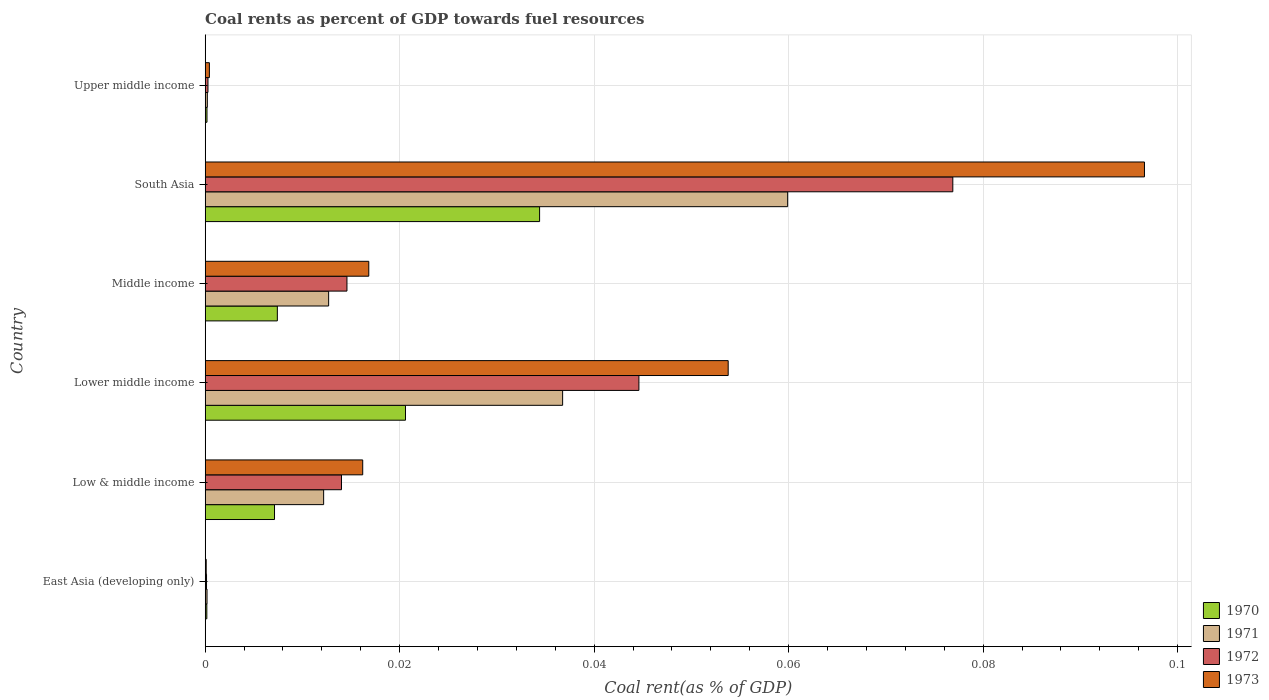How many groups of bars are there?
Provide a succinct answer. 6. Are the number of bars per tick equal to the number of legend labels?
Offer a very short reply. Yes. Are the number of bars on each tick of the Y-axis equal?
Your answer should be compact. Yes. How many bars are there on the 4th tick from the bottom?
Keep it short and to the point. 4. In how many cases, is the number of bars for a given country not equal to the number of legend labels?
Ensure brevity in your answer.  0. What is the coal rent in 1972 in East Asia (developing only)?
Keep it short and to the point. 0. Across all countries, what is the maximum coal rent in 1971?
Your answer should be compact. 0.06. Across all countries, what is the minimum coal rent in 1972?
Make the answer very short. 0. In which country was the coal rent in 1971 maximum?
Provide a short and direct response. South Asia. In which country was the coal rent in 1970 minimum?
Make the answer very short. East Asia (developing only). What is the total coal rent in 1971 in the graph?
Your response must be concise. 0.12. What is the difference between the coal rent in 1972 in Low & middle income and that in Lower middle income?
Your answer should be compact. -0.03. What is the difference between the coal rent in 1973 in Middle income and the coal rent in 1971 in Upper middle income?
Your response must be concise. 0.02. What is the average coal rent in 1973 per country?
Make the answer very short. 0.03. What is the difference between the coal rent in 1973 and coal rent in 1970 in South Asia?
Provide a short and direct response. 0.06. What is the ratio of the coal rent in 1973 in Lower middle income to that in South Asia?
Your response must be concise. 0.56. Is the coal rent in 1972 in East Asia (developing only) less than that in Upper middle income?
Make the answer very short. Yes. What is the difference between the highest and the second highest coal rent in 1970?
Provide a succinct answer. 0.01. What is the difference between the highest and the lowest coal rent in 1970?
Your response must be concise. 0.03. Is the sum of the coal rent in 1973 in Middle income and Upper middle income greater than the maximum coal rent in 1970 across all countries?
Your answer should be compact. No. What does the 2nd bar from the top in Lower middle income represents?
Offer a very short reply. 1972. What does the 4th bar from the bottom in East Asia (developing only) represents?
Your answer should be very brief. 1973. Is it the case that in every country, the sum of the coal rent in 1970 and coal rent in 1971 is greater than the coal rent in 1972?
Your response must be concise. Yes. How many bars are there?
Give a very brief answer. 24. How many countries are there in the graph?
Provide a short and direct response. 6. Does the graph contain any zero values?
Keep it short and to the point. No. Does the graph contain grids?
Keep it short and to the point. Yes. Where does the legend appear in the graph?
Make the answer very short. Bottom right. How many legend labels are there?
Give a very brief answer. 4. What is the title of the graph?
Your answer should be compact. Coal rents as percent of GDP towards fuel resources. What is the label or title of the X-axis?
Provide a short and direct response. Coal rent(as % of GDP). What is the Coal rent(as % of GDP) of 1970 in East Asia (developing only)?
Keep it short and to the point. 0. What is the Coal rent(as % of GDP) in 1971 in East Asia (developing only)?
Your response must be concise. 0. What is the Coal rent(as % of GDP) in 1972 in East Asia (developing only)?
Provide a short and direct response. 0. What is the Coal rent(as % of GDP) of 1973 in East Asia (developing only)?
Make the answer very short. 0. What is the Coal rent(as % of GDP) of 1970 in Low & middle income?
Keep it short and to the point. 0.01. What is the Coal rent(as % of GDP) in 1971 in Low & middle income?
Your answer should be very brief. 0.01. What is the Coal rent(as % of GDP) of 1972 in Low & middle income?
Provide a short and direct response. 0.01. What is the Coal rent(as % of GDP) in 1973 in Low & middle income?
Your answer should be very brief. 0.02. What is the Coal rent(as % of GDP) of 1970 in Lower middle income?
Keep it short and to the point. 0.02. What is the Coal rent(as % of GDP) in 1971 in Lower middle income?
Give a very brief answer. 0.04. What is the Coal rent(as % of GDP) of 1972 in Lower middle income?
Give a very brief answer. 0.04. What is the Coal rent(as % of GDP) of 1973 in Lower middle income?
Offer a terse response. 0.05. What is the Coal rent(as % of GDP) of 1970 in Middle income?
Your response must be concise. 0.01. What is the Coal rent(as % of GDP) in 1971 in Middle income?
Your answer should be very brief. 0.01. What is the Coal rent(as % of GDP) in 1972 in Middle income?
Ensure brevity in your answer.  0.01. What is the Coal rent(as % of GDP) in 1973 in Middle income?
Provide a succinct answer. 0.02. What is the Coal rent(as % of GDP) of 1970 in South Asia?
Your response must be concise. 0.03. What is the Coal rent(as % of GDP) in 1971 in South Asia?
Offer a terse response. 0.06. What is the Coal rent(as % of GDP) in 1972 in South Asia?
Give a very brief answer. 0.08. What is the Coal rent(as % of GDP) in 1973 in South Asia?
Keep it short and to the point. 0.1. What is the Coal rent(as % of GDP) of 1970 in Upper middle income?
Your answer should be very brief. 0. What is the Coal rent(as % of GDP) in 1971 in Upper middle income?
Your answer should be compact. 0. What is the Coal rent(as % of GDP) in 1972 in Upper middle income?
Offer a terse response. 0. What is the Coal rent(as % of GDP) in 1973 in Upper middle income?
Ensure brevity in your answer.  0. Across all countries, what is the maximum Coal rent(as % of GDP) of 1970?
Make the answer very short. 0.03. Across all countries, what is the maximum Coal rent(as % of GDP) of 1971?
Your answer should be very brief. 0.06. Across all countries, what is the maximum Coal rent(as % of GDP) in 1972?
Offer a very short reply. 0.08. Across all countries, what is the maximum Coal rent(as % of GDP) of 1973?
Provide a short and direct response. 0.1. Across all countries, what is the minimum Coal rent(as % of GDP) of 1970?
Ensure brevity in your answer.  0. Across all countries, what is the minimum Coal rent(as % of GDP) of 1971?
Provide a succinct answer. 0. Across all countries, what is the minimum Coal rent(as % of GDP) of 1972?
Ensure brevity in your answer.  0. Across all countries, what is the minimum Coal rent(as % of GDP) in 1973?
Your response must be concise. 0. What is the total Coal rent(as % of GDP) in 1970 in the graph?
Your answer should be compact. 0.07. What is the total Coal rent(as % of GDP) of 1971 in the graph?
Offer a very short reply. 0.12. What is the total Coal rent(as % of GDP) in 1972 in the graph?
Make the answer very short. 0.15. What is the total Coal rent(as % of GDP) in 1973 in the graph?
Ensure brevity in your answer.  0.18. What is the difference between the Coal rent(as % of GDP) in 1970 in East Asia (developing only) and that in Low & middle income?
Offer a very short reply. -0.01. What is the difference between the Coal rent(as % of GDP) of 1971 in East Asia (developing only) and that in Low & middle income?
Give a very brief answer. -0.01. What is the difference between the Coal rent(as % of GDP) in 1972 in East Asia (developing only) and that in Low & middle income?
Your answer should be compact. -0.01. What is the difference between the Coal rent(as % of GDP) in 1973 in East Asia (developing only) and that in Low & middle income?
Provide a short and direct response. -0.02. What is the difference between the Coal rent(as % of GDP) in 1970 in East Asia (developing only) and that in Lower middle income?
Provide a succinct answer. -0.02. What is the difference between the Coal rent(as % of GDP) in 1971 in East Asia (developing only) and that in Lower middle income?
Your answer should be very brief. -0.04. What is the difference between the Coal rent(as % of GDP) in 1972 in East Asia (developing only) and that in Lower middle income?
Your answer should be compact. -0.04. What is the difference between the Coal rent(as % of GDP) of 1973 in East Asia (developing only) and that in Lower middle income?
Provide a succinct answer. -0.05. What is the difference between the Coal rent(as % of GDP) in 1970 in East Asia (developing only) and that in Middle income?
Your answer should be compact. -0.01. What is the difference between the Coal rent(as % of GDP) in 1971 in East Asia (developing only) and that in Middle income?
Provide a short and direct response. -0.01. What is the difference between the Coal rent(as % of GDP) of 1972 in East Asia (developing only) and that in Middle income?
Ensure brevity in your answer.  -0.01. What is the difference between the Coal rent(as % of GDP) in 1973 in East Asia (developing only) and that in Middle income?
Offer a very short reply. -0.02. What is the difference between the Coal rent(as % of GDP) in 1970 in East Asia (developing only) and that in South Asia?
Your answer should be compact. -0.03. What is the difference between the Coal rent(as % of GDP) of 1971 in East Asia (developing only) and that in South Asia?
Your answer should be compact. -0.06. What is the difference between the Coal rent(as % of GDP) in 1972 in East Asia (developing only) and that in South Asia?
Offer a very short reply. -0.08. What is the difference between the Coal rent(as % of GDP) in 1973 in East Asia (developing only) and that in South Asia?
Give a very brief answer. -0.1. What is the difference between the Coal rent(as % of GDP) of 1970 in East Asia (developing only) and that in Upper middle income?
Provide a short and direct response. -0. What is the difference between the Coal rent(as % of GDP) in 1972 in East Asia (developing only) and that in Upper middle income?
Your answer should be very brief. -0. What is the difference between the Coal rent(as % of GDP) in 1973 in East Asia (developing only) and that in Upper middle income?
Offer a very short reply. -0. What is the difference between the Coal rent(as % of GDP) in 1970 in Low & middle income and that in Lower middle income?
Make the answer very short. -0.01. What is the difference between the Coal rent(as % of GDP) of 1971 in Low & middle income and that in Lower middle income?
Provide a short and direct response. -0.02. What is the difference between the Coal rent(as % of GDP) of 1972 in Low & middle income and that in Lower middle income?
Keep it short and to the point. -0.03. What is the difference between the Coal rent(as % of GDP) in 1973 in Low & middle income and that in Lower middle income?
Provide a succinct answer. -0.04. What is the difference between the Coal rent(as % of GDP) of 1970 in Low & middle income and that in Middle income?
Your answer should be compact. -0. What is the difference between the Coal rent(as % of GDP) in 1971 in Low & middle income and that in Middle income?
Your answer should be very brief. -0. What is the difference between the Coal rent(as % of GDP) in 1972 in Low & middle income and that in Middle income?
Provide a succinct answer. -0. What is the difference between the Coal rent(as % of GDP) of 1973 in Low & middle income and that in Middle income?
Keep it short and to the point. -0. What is the difference between the Coal rent(as % of GDP) of 1970 in Low & middle income and that in South Asia?
Your answer should be very brief. -0.03. What is the difference between the Coal rent(as % of GDP) of 1971 in Low & middle income and that in South Asia?
Provide a short and direct response. -0.05. What is the difference between the Coal rent(as % of GDP) of 1972 in Low & middle income and that in South Asia?
Offer a very short reply. -0.06. What is the difference between the Coal rent(as % of GDP) in 1973 in Low & middle income and that in South Asia?
Make the answer very short. -0.08. What is the difference between the Coal rent(as % of GDP) of 1970 in Low & middle income and that in Upper middle income?
Offer a terse response. 0.01. What is the difference between the Coal rent(as % of GDP) of 1971 in Low & middle income and that in Upper middle income?
Give a very brief answer. 0.01. What is the difference between the Coal rent(as % of GDP) of 1972 in Low & middle income and that in Upper middle income?
Keep it short and to the point. 0.01. What is the difference between the Coal rent(as % of GDP) of 1973 in Low & middle income and that in Upper middle income?
Ensure brevity in your answer.  0.02. What is the difference between the Coal rent(as % of GDP) in 1970 in Lower middle income and that in Middle income?
Keep it short and to the point. 0.01. What is the difference between the Coal rent(as % of GDP) in 1971 in Lower middle income and that in Middle income?
Give a very brief answer. 0.02. What is the difference between the Coal rent(as % of GDP) of 1972 in Lower middle income and that in Middle income?
Ensure brevity in your answer.  0.03. What is the difference between the Coal rent(as % of GDP) of 1973 in Lower middle income and that in Middle income?
Offer a very short reply. 0.04. What is the difference between the Coal rent(as % of GDP) of 1970 in Lower middle income and that in South Asia?
Keep it short and to the point. -0.01. What is the difference between the Coal rent(as % of GDP) in 1971 in Lower middle income and that in South Asia?
Give a very brief answer. -0.02. What is the difference between the Coal rent(as % of GDP) in 1972 in Lower middle income and that in South Asia?
Ensure brevity in your answer.  -0.03. What is the difference between the Coal rent(as % of GDP) of 1973 in Lower middle income and that in South Asia?
Your answer should be compact. -0.04. What is the difference between the Coal rent(as % of GDP) of 1970 in Lower middle income and that in Upper middle income?
Your response must be concise. 0.02. What is the difference between the Coal rent(as % of GDP) in 1971 in Lower middle income and that in Upper middle income?
Offer a very short reply. 0.04. What is the difference between the Coal rent(as % of GDP) of 1972 in Lower middle income and that in Upper middle income?
Provide a short and direct response. 0.04. What is the difference between the Coal rent(as % of GDP) of 1973 in Lower middle income and that in Upper middle income?
Your answer should be very brief. 0.05. What is the difference between the Coal rent(as % of GDP) in 1970 in Middle income and that in South Asia?
Your response must be concise. -0.03. What is the difference between the Coal rent(as % of GDP) of 1971 in Middle income and that in South Asia?
Your answer should be very brief. -0.05. What is the difference between the Coal rent(as % of GDP) in 1972 in Middle income and that in South Asia?
Provide a succinct answer. -0.06. What is the difference between the Coal rent(as % of GDP) in 1973 in Middle income and that in South Asia?
Make the answer very short. -0.08. What is the difference between the Coal rent(as % of GDP) of 1970 in Middle income and that in Upper middle income?
Your answer should be very brief. 0.01. What is the difference between the Coal rent(as % of GDP) in 1971 in Middle income and that in Upper middle income?
Provide a succinct answer. 0.01. What is the difference between the Coal rent(as % of GDP) in 1972 in Middle income and that in Upper middle income?
Make the answer very short. 0.01. What is the difference between the Coal rent(as % of GDP) in 1973 in Middle income and that in Upper middle income?
Give a very brief answer. 0.02. What is the difference between the Coal rent(as % of GDP) of 1970 in South Asia and that in Upper middle income?
Make the answer very short. 0.03. What is the difference between the Coal rent(as % of GDP) of 1971 in South Asia and that in Upper middle income?
Offer a very short reply. 0.06. What is the difference between the Coal rent(as % of GDP) of 1972 in South Asia and that in Upper middle income?
Offer a very short reply. 0.08. What is the difference between the Coal rent(as % of GDP) in 1973 in South Asia and that in Upper middle income?
Provide a short and direct response. 0.1. What is the difference between the Coal rent(as % of GDP) in 1970 in East Asia (developing only) and the Coal rent(as % of GDP) in 1971 in Low & middle income?
Keep it short and to the point. -0.01. What is the difference between the Coal rent(as % of GDP) in 1970 in East Asia (developing only) and the Coal rent(as % of GDP) in 1972 in Low & middle income?
Ensure brevity in your answer.  -0.01. What is the difference between the Coal rent(as % of GDP) in 1970 in East Asia (developing only) and the Coal rent(as % of GDP) in 1973 in Low & middle income?
Your answer should be very brief. -0.02. What is the difference between the Coal rent(as % of GDP) in 1971 in East Asia (developing only) and the Coal rent(as % of GDP) in 1972 in Low & middle income?
Provide a succinct answer. -0.01. What is the difference between the Coal rent(as % of GDP) in 1971 in East Asia (developing only) and the Coal rent(as % of GDP) in 1973 in Low & middle income?
Give a very brief answer. -0.02. What is the difference between the Coal rent(as % of GDP) of 1972 in East Asia (developing only) and the Coal rent(as % of GDP) of 1973 in Low & middle income?
Provide a short and direct response. -0.02. What is the difference between the Coal rent(as % of GDP) of 1970 in East Asia (developing only) and the Coal rent(as % of GDP) of 1971 in Lower middle income?
Offer a terse response. -0.04. What is the difference between the Coal rent(as % of GDP) of 1970 in East Asia (developing only) and the Coal rent(as % of GDP) of 1972 in Lower middle income?
Give a very brief answer. -0.04. What is the difference between the Coal rent(as % of GDP) of 1970 in East Asia (developing only) and the Coal rent(as % of GDP) of 1973 in Lower middle income?
Offer a terse response. -0.05. What is the difference between the Coal rent(as % of GDP) in 1971 in East Asia (developing only) and the Coal rent(as % of GDP) in 1972 in Lower middle income?
Make the answer very short. -0.04. What is the difference between the Coal rent(as % of GDP) of 1971 in East Asia (developing only) and the Coal rent(as % of GDP) of 1973 in Lower middle income?
Make the answer very short. -0.05. What is the difference between the Coal rent(as % of GDP) of 1972 in East Asia (developing only) and the Coal rent(as % of GDP) of 1973 in Lower middle income?
Keep it short and to the point. -0.05. What is the difference between the Coal rent(as % of GDP) in 1970 in East Asia (developing only) and the Coal rent(as % of GDP) in 1971 in Middle income?
Your answer should be very brief. -0.01. What is the difference between the Coal rent(as % of GDP) of 1970 in East Asia (developing only) and the Coal rent(as % of GDP) of 1972 in Middle income?
Ensure brevity in your answer.  -0.01. What is the difference between the Coal rent(as % of GDP) of 1970 in East Asia (developing only) and the Coal rent(as % of GDP) of 1973 in Middle income?
Provide a short and direct response. -0.02. What is the difference between the Coal rent(as % of GDP) in 1971 in East Asia (developing only) and the Coal rent(as % of GDP) in 1972 in Middle income?
Make the answer very short. -0.01. What is the difference between the Coal rent(as % of GDP) in 1971 in East Asia (developing only) and the Coal rent(as % of GDP) in 1973 in Middle income?
Your answer should be very brief. -0.02. What is the difference between the Coal rent(as % of GDP) in 1972 in East Asia (developing only) and the Coal rent(as % of GDP) in 1973 in Middle income?
Provide a succinct answer. -0.02. What is the difference between the Coal rent(as % of GDP) of 1970 in East Asia (developing only) and the Coal rent(as % of GDP) of 1971 in South Asia?
Your answer should be very brief. -0.06. What is the difference between the Coal rent(as % of GDP) in 1970 in East Asia (developing only) and the Coal rent(as % of GDP) in 1972 in South Asia?
Your answer should be very brief. -0.08. What is the difference between the Coal rent(as % of GDP) in 1970 in East Asia (developing only) and the Coal rent(as % of GDP) in 1973 in South Asia?
Ensure brevity in your answer.  -0.1. What is the difference between the Coal rent(as % of GDP) of 1971 in East Asia (developing only) and the Coal rent(as % of GDP) of 1972 in South Asia?
Make the answer very short. -0.08. What is the difference between the Coal rent(as % of GDP) of 1971 in East Asia (developing only) and the Coal rent(as % of GDP) of 1973 in South Asia?
Keep it short and to the point. -0.1. What is the difference between the Coal rent(as % of GDP) in 1972 in East Asia (developing only) and the Coal rent(as % of GDP) in 1973 in South Asia?
Offer a very short reply. -0.1. What is the difference between the Coal rent(as % of GDP) of 1970 in East Asia (developing only) and the Coal rent(as % of GDP) of 1971 in Upper middle income?
Keep it short and to the point. -0. What is the difference between the Coal rent(as % of GDP) in 1970 in East Asia (developing only) and the Coal rent(as % of GDP) in 1972 in Upper middle income?
Your response must be concise. -0. What is the difference between the Coal rent(as % of GDP) of 1970 in East Asia (developing only) and the Coal rent(as % of GDP) of 1973 in Upper middle income?
Give a very brief answer. -0. What is the difference between the Coal rent(as % of GDP) of 1971 in East Asia (developing only) and the Coal rent(as % of GDP) of 1972 in Upper middle income?
Offer a very short reply. -0. What is the difference between the Coal rent(as % of GDP) in 1971 in East Asia (developing only) and the Coal rent(as % of GDP) in 1973 in Upper middle income?
Give a very brief answer. -0. What is the difference between the Coal rent(as % of GDP) in 1972 in East Asia (developing only) and the Coal rent(as % of GDP) in 1973 in Upper middle income?
Your response must be concise. -0. What is the difference between the Coal rent(as % of GDP) of 1970 in Low & middle income and the Coal rent(as % of GDP) of 1971 in Lower middle income?
Provide a short and direct response. -0.03. What is the difference between the Coal rent(as % of GDP) of 1970 in Low & middle income and the Coal rent(as % of GDP) of 1972 in Lower middle income?
Provide a short and direct response. -0.04. What is the difference between the Coal rent(as % of GDP) in 1970 in Low & middle income and the Coal rent(as % of GDP) in 1973 in Lower middle income?
Keep it short and to the point. -0.05. What is the difference between the Coal rent(as % of GDP) of 1971 in Low & middle income and the Coal rent(as % of GDP) of 1972 in Lower middle income?
Keep it short and to the point. -0.03. What is the difference between the Coal rent(as % of GDP) in 1971 in Low & middle income and the Coal rent(as % of GDP) in 1973 in Lower middle income?
Keep it short and to the point. -0.04. What is the difference between the Coal rent(as % of GDP) of 1972 in Low & middle income and the Coal rent(as % of GDP) of 1973 in Lower middle income?
Your answer should be very brief. -0.04. What is the difference between the Coal rent(as % of GDP) in 1970 in Low & middle income and the Coal rent(as % of GDP) in 1971 in Middle income?
Keep it short and to the point. -0.01. What is the difference between the Coal rent(as % of GDP) in 1970 in Low & middle income and the Coal rent(as % of GDP) in 1972 in Middle income?
Provide a succinct answer. -0.01. What is the difference between the Coal rent(as % of GDP) of 1970 in Low & middle income and the Coal rent(as % of GDP) of 1973 in Middle income?
Keep it short and to the point. -0.01. What is the difference between the Coal rent(as % of GDP) in 1971 in Low & middle income and the Coal rent(as % of GDP) in 1972 in Middle income?
Make the answer very short. -0. What is the difference between the Coal rent(as % of GDP) of 1971 in Low & middle income and the Coal rent(as % of GDP) of 1973 in Middle income?
Offer a very short reply. -0. What is the difference between the Coal rent(as % of GDP) of 1972 in Low & middle income and the Coal rent(as % of GDP) of 1973 in Middle income?
Provide a short and direct response. -0. What is the difference between the Coal rent(as % of GDP) in 1970 in Low & middle income and the Coal rent(as % of GDP) in 1971 in South Asia?
Keep it short and to the point. -0.05. What is the difference between the Coal rent(as % of GDP) in 1970 in Low & middle income and the Coal rent(as % of GDP) in 1972 in South Asia?
Your answer should be compact. -0.07. What is the difference between the Coal rent(as % of GDP) of 1970 in Low & middle income and the Coal rent(as % of GDP) of 1973 in South Asia?
Provide a succinct answer. -0.09. What is the difference between the Coal rent(as % of GDP) of 1971 in Low & middle income and the Coal rent(as % of GDP) of 1972 in South Asia?
Your answer should be very brief. -0.06. What is the difference between the Coal rent(as % of GDP) of 1971 in Low & middle income and the Coal rent(as % of GDP) of 1973 in South Asia?
Offer a very short reply. -0.08. What is the difference between the Coal rent(as % of GDP) of 1972 in Low & middle income and the Coal rent(as % of GDP) of 1973 in South Asia?
Make the answer very short. -0.08. What is the difference between the Coal rent(as % of GDP) of 1970 in Low & middle income and the Coal rent(as % of GDP) of 1971 in Upper middle income?
Make the answer very short. 0.01. What is the difference between the Coal rent(as % of GDP) of 1970 in Low & middle income and the Coal rent(as % of GDP) of 1972 in Upper middle income?
Your answer should be very brief. 0.01. What is the difference between the Coal rent(as % of GDP) of 1970 in Low & middle income and the Coal rent(as % of GDP) of 1973 in Upper middle income?
Ensure brevity in your answer.  0.01. What is the difference between the Coal rent(as % of GDP) of 1971 in Low & middle income and the Coal rent(as % of GDP) of 1972 in Upper middle income?
Provide a succinct answer. 0.01. What is the difference between the Coal rent(as % of GDP) in 1971 in Low & middle income and the Coal rent(as % of GDP) in 1973 in Upper middle income?
Offer a very short reply. 0.01. What is the difference between the Coal rent(as % of GDP) of 1972 in Low & middle income and the Coal rent(as % of GDP) of 1973 in Upper middle income?
Make the answer very short. 0.01. What is the difference between the Coal rent(as % of GDP) of 1970 in Lower middle income and the Coal rent(as % of GDP) of 1971 in Middle income?
Provide a short and direct response. 0.01. What is the difference between the Coal rent(as % of GDP) in 1970 in Lower middle income and the Coal rent(as % of GDP) in 1972 in Middle income?
Your answer should be very brief. 0.01. What is the difference between the Coal rent(as % of GDP) of 1970 in Lower middle income and the Coal rent(as % of GDP) of 1973 in Middle income?
Ensure brevity in your answer.  0. What is the difference between the Coal rent(as % of GDP) in 1971 in Lower middle income and the Coal rent(as % of GDP) in 1972 in Middle income?
Your answer should be compact. 0.02. What is the difference between the Coal rent(as % of GDP) of 1971 in Lower middle income and the Coal rent(as % of GDP) of 1973 in Middle income?
Provide a succinct answer. 0.02. What is the difference between the Coal rent(as % of GDP) of 1972 in Lower middle income and the Coal rent(as % of GDP) of 1973 in Middle income?
Offer a very short reply. 0.03. What is the difference between the Coal rent(as % of GDP) in 1970 in Lower middle income and the Coal rent(as % of GDP) in 1971 in South Asia?
Provide a succinct answer. -0.04. What is the difference between the Coal rent(as % of GDP) in 1970 in Lower middle income and the Coal rent(as % of GDP) in 1972 in South Asia?
Your answer should be very brief. -0.06. What is the difference between the Coal rent(as % of GDP) of 1970 in Lower middle income and the Coal rent(as % of GDP) of 1973 in South Asia?
Provide a succinct answer. -0.08. What is the difference between the Coal rent(as % of GDP) of 1971 in Lower middle income and the Coal rent(as % of GDP) of 1972 in South Asia?
Your answer should be compact. -0.04. What is the difference between the Coal rent(as % of GDP) of 1971 in Lower middle income and the Coal rent(as % of GDP) of 1973 in South Asia?
Make the answer very short. -0.06. What is the difference between the Coal rent(as % of GDP) of 1972 in Lower middle income and the Coal rent(as % of GDP) of 1973 in South Asia?
Provide a succinct answer. -0.05. What is the difference between the Coal rent(as % of GDP) in 1970 in Lower middle income and the Coal rent(as % of GDP) in 1971 in Upper middle income?
Offer a terse response. 0.02. What is the difference between the Coal rent(as % of GDP) of 1970 in Lower middle income and the Coal rent(as % of GDP) of 1972 in Upper middle income?
Your answer should be compact. 0.02. What is the difference between the Coal rent(as % of GDP) in 1970 in Lower middle income and the Coal rent(as % of GDP) in 1973 in Upper middle income?
Ensure brevity in your answer.  0.02. What is the difference between the Coal rent(as % of GDP) in 1971 in Lower middle income and the Coal rent(as % of GDP) in 1972 in Upper middle income?
Offer a very short reply. 0.04. What is the difference between the Coal rent(as % of GDP) in 1971 in Lower middle income and the Coal rent(as % of GDP) in 1973 in Upper middle income?
Provide a succinct answer. 0.04. What is the difference between the Coal rent(as % of GDP) in 1972 in Lower middle income and the Coal rent(as % of GDP) in 1973 in Upper middle income?
Keep it short and to the point. 0.04. What is the difference between the Coal rent(as % of GDP) of 1970 in Middle income and the Coal rent(as % of GDP) of 1971 in South Asia?
Provide a succinct answer. -0.05. What is the difference between the Coal rent(as % of GDP) in 1970 in Middle income and the Coal rent(as % of GDP) in 1972 in South Asia?
Your answer should be compact. -0.07. What is the difference between the Coal rent(as % of GDP) of 1970 in Middle income and the Coal rent(as % of GDP) of 1973 in South Asia?
Provide a succinct answer. -0.09. What is the difference between the Coal rent(as % of GDP) in 1971 in Middle income and the Coal rent(as % of GDP) in 1972 in South Asia?
Make the answer very short. -0.06. What is the difference between the Coal rent(as % of GDP) of 1971 in Middle income and the Coal rent(as % of GDP) of 1973 in South Asia?
Your answer should be compact. -0.08. What is the difference between the Coal rent(as % of GDP) in 1972 in Middle income and the Coal rent(as % of GDP) in 1973 in South Asia?
Provide a short and direct response. -0.08. What is the difference between the Coal rent(as % of GDP) in 1970 in Middle income and the Coal rent(as % of GDP) in 1971 in Upper middle income?
Your answer should be compact. 0.01. What is the difference between the Coal rent(as % of GDP) in 1970 in Middle income and the Coal rent(as % of GDP) in 1972 in Upper middle income?
Your answer should be compact. 0.01. What is the difference between the Coal rent(as % of GDP) in 1970 in Middle income and the Coal rent(as % of GDP) in 1973 in Upper middle income?
Your response must be concise. 0.01. What is the difference between the Coal rent(as % of GDP) in 1971 in Middle income and the Coal rent(as % of GDP) in 1972 in Upper middle income?
Provide a succinct answer. 0.01. What is the difference between the Coal rent(as % of GDP) of 1971 in Middle income and the Coal rent(as % of GDP) of 1973 in Upper middle income?
Make the answer very short. 0.01. What is the difference between the Coal rent(as % of GDP) of 1972 in Middle income and the Coal rent(as % of GDP) of 1973 in Upper middle income?
Provide a short and direct response. 0.01. What is the difference between the Coal rent(as % of GDP) in 1970 in South Asia and the Coal rent(as % of GDP) in 1971 in Upper middle income?
Offer a terse response. 0.03. What is the difference between the Coal rent(as % of GDP) in 1970 in South Asia and the Coal rent(as % of GDP) in 1972 in Upper middle income?
Your response must be concise. 0.03. What is the difference between the Coal rent(as % of GDP) of 1970 in South Asia and the Coal rent(as % of GDP) of 1973 in Upper middle income?
Your answer should be compact. 0.03. What is the difference between the Coal rent(as % of GDP) in 1971 in South Asia and the Coal rent(as % of GDP) in 1972 in Upper middle income?
Your response must be concise. 0.06. What is the difference between the Coal rent(as % of GDP) in 1971 in South Asia and the Coal rent(as % of GDP) in 1973 in Upper middle income?
Keep it short and to the point. 0.06. What is the difference between the Coal rent(as % of GDP) of 1972 in South Asia and the Coal rent(as % of GDP) of 1973 in Upper middle income?
Provide a succinct answer. 0.08. What is the average Coal rent(as % of GDP) in 1970 per country?
Offer a terse response. 0.01. What is the average Coal rent(as % of GDP) in 1971 per country?
Your response must be concise. 0.02. What is the average Coal rent(as % of GDP) of 1972 per country?
Your answer should be compact. 0.03. What is the average Coal rent(as % of GDP) of 1973 per country?
Offer a terse response. 0.03. What is the difference between the Coal rent(as % of GDP) in 1970 and Coal rent(as % of GDP) in 1972 in East Asia (developing only)?
Ensure brevity in your answer.  0. What is the difference between the Coal rent(as % of GDP) in 1970 and Coal rent(as % of GDP) in 1973 in East Asia (developing only)?
Your answer should be very brief. 0. What is the difference between the Coal rent(as % of GDP) in 1971 and Coal rent(as % of GDP) in 1973 in East Asia (developing only)?
Your response must be concise. 0. What is the difference between the Coal rent(as % of GDP) in 1972 and Coal rent(as % of GDP) in 1973 in East Asia (developing only)?
Provide a succinct answer. 0. What is the difference between the Coal rent(as % of GDP) in 1970 and Coal rent(as % of GDP) in 1971 in Low & middle income?
Provide a short and direct response. -0.01. What is the difference between the Coal rent(as % of GDP) in 1970 and Coal rent(as % of GDP) in 1972 in Low & middle income?
Offer a terse response. -0.01. What is the difference between the Coal rent(as % of GDP) of 1970 and Coal rent(as % of GDP) of 1973 in Low & middle income?
Ensure brevity in your answer.  -0.01. What is the difference between the Coal rent(as % of GDP) of 1971 and Coal rent(as % of GDP) of 1972 in Low & middle income?
Your answer should be very brief. -0. What is the difference between the Coal rent(as % of GDP) of 1971 and Coal rent(as % of GDP) of 1973 in Low & middle income?
Your answer should be very brief. -0. What is the difference between the Coal rent(as % of GDP) in 1972 and Coal rent(as % of GDP) in 1973 in Low & middle income?
Offer a terse response. -0. What is the difference between the Coal rent(as % of GDP) of 1970 and Coal rent(as % of GDP) of 1971 in Lower middle income?
Your answer should be very brief. -0.02. What is the difference between the Coal rent(as % of GDP) of 1970 and Coal rent(as % of GDP) of 1972 in Lower middle income?
Provide a short and direct response. -0.02. What is the difference between the Coal rent(as % of GDP) of 1970 and Coal rent(as % of GDP) of 1973 in Lower middle income?
Ensure brevity in your answer.  -0.03. What is the difference between the Coal rent(as % of GDP) of 1971 and Coal rent(as % of GDP) of 1972 in Lower middle income?
Your answer should be very brief. -0.01. What is the difference between the Coal rent(as % of GDP) of 1971 and Coal rent(as % of GDP) of 1973 in Lower middle income?
Give a very brief answer. -0.02. What is the difference between the Coal rent(as % of GDP) in 1972 and Coal rent(as % of GDP) in 1973 in Lower middle income?
Make the answer very short. -0.01. What is the difference between the Coal rent(as % of GDP) of 1970 and Coal rent(as % of GDP) of 1971 in Middle income?
Your answer should be very brief. -0.01. What is the difference between the Coal rent(as % of GDP) in 1970 and Coal rent(as % of GDP) in 1972 in Middle income?
Your answer should be very brief. -0.01. What is the difference between the Coal rent(as % of GDP) in 1970 and Coal rent(as % of GDP) in 1973 in Middle income?
Your response must be concise. -0.01. What is the difference between the Coal rent(as % of GDP) in 1971 and Coal rent(as % of GDP) in 1972 in Middle income?
Your answer should be very brief. -0. What is the difference between the Coal rent(as % of GDP) in 1971 and Coal rent(as % of GDP) in 1973 in Middle income?
Ensure brevity in your answer.  -0. What is the difference between the Coal rent(as % of GDP) of 1972 and Coal rent(as % of GDP) of 1973 in Middle income?
Ensure brevity in your answer.  -0. What is the difference between the Coal rent(as % of GDP) in 1970 and Coal rent(as % of GDP) in 1971 in South Asia?
Your answer should be very brief. -0.03. What is the difference between the Coal rent(as % of GDP) of 1970 and Coal rent(as % of GDP) of 1972 in South Asia?
Make the answer very short. -0.04. What is the difference between the Coal rent(as % of GDP) in 1970 and Coal rent(as % of GDP) in 1973 in South Asia?
Make the answer very short. -0.06. What is the difference between the Coal rent(as % of GDP) of 1971 and Coal rent(as % of GDP) of 1972 in South Asia?
Provide a succinct answer. -0.02. What is the difference between the Coal rent(as % of GDP) of 1971 and Coal rent(as % of GDP) of 1973 in South Asia?
Make the answer very short. -0.04. What is the difference between the Coal rent(as % of GDP) of 1972 and Coal rent(as % of GDP) of 1973 in South Asia?
Offer a very short reply. -0.02. What is the difference between the Coal rent(as % of GDP) in 1970 and Coal rent(as % of GDP) in 1971 in Upper middle income?
Provide a short and direct response. -0. What is the difference between the Coal rent(as % of GDP) in 1970 and Coal rent(as % of GDP) in 1972 in Upper middle income?
Provide a short and direct response. -0. What is the difference between the Coal rent(as % of GDP) of 1970 and Coal rent(as % of GDP) of 1973 in Upper middle income?
Keep it short and to the point. -0. What is the difference between the Coal rent(as % of GDP) in 1971 and Coal rent(as % of GDP) in 1972 in Upper middle income?
Provide a succinct answer. -0. What is the difference between the Coal rent(as % of GDP) in 1971 and Coal rent(as % of GDP) in 1973 in Upper middle income?
Provide a succinct answer. -0. What is the difference between the Coal rent(as % of GDP) in 1972 and Coal rent(as % of GDP) in 1973 in Upper middle income?
Keep it short and to the point. -0. What is the ratio of the Coal rent(as % of GDP) of 1970 in East Asia (developing only) to that in Low & middle income?
Offer a terse response. 0.02. What is the ratio of the Coal rent(as % of GDP) of 1971 in East Asia (developing only) to that in Low & middle income?
Ensure brevity in your answer.  0.02. What is the ratio of the Coal rent(as % of GDP) of 1972 in East Asia (developing only) to that in Low & middle income?
Ensure brevity in your answer.  0.01. What is the ratio of the Coal rent(as % of GDP) of 1973 in East Asia (developing only) to that in Low & middle income?
Keep it short and to the point. 0.01. What is the ratio of the Coal rent(as % of GDP) of 1970 in East Asia (developing only) to that in Lower middle income?
Give a very brief answer. 0.01. What is the ratio of the Coal rent(as % of GDP) in 1971 in East Asia (developing only) to that in Lower middle income?
Keep it short and to the point. 0.01. What is the ratio of the Coal rent(as % of GDP) of 1972 in East Asia (developing only) to that in Lower middle income?
Make the answer very short. 0. What is the ratio of the Coal rent(as % of GDP) in 1973 in East Asia (developing only) to that in Lower middle income?
Give a very brief answer. 0. What is the ratio of the Coal rent(as % of GDP) of 1970 in East Asia (developing only) to that in Middle income?
Your answer should be very brief. 0.02. What is the ratio of the Coal rent(as % of GDP) of 1971 in East Asia (developing only) to that in Middle income?
Provide a succinct answer. 0.01. What is the ratio of the Coal rent(as % of GDP) in 1972 in East Asia (developing only) to that in Middle income?
Give a very brief answer. 0.01. What is the ratio of the Coal rent(as % of GDP) of 1973 in East Asia (developing only) to that in Middle income?
Provide a succinct answer. 0.01. What is the ratio of the Coal rent(as % of GDP) in 1970 in East Asia (developing only) to that in South Asia?
Keep it short and to the point. 0. What is the ratio of the Coal rent(as % of GDP) in 1971 in East Asia (developing only) to that in South Asia?
Offer a terse response. 0. What is the ratio of the Coal rent(as % of GDP) in 1972 in East Asia (developing only) to that in South Asia?
Give a very brief answer. 0. What is the ratio of the Coal rent(as % of GDP) of 1973 in East Asia (developing only) to that in South Asia?
Offer a very short reply. 0. What is the ratio of the Coal rent(as % of GDP) of 1970 in East Asia (developing only) to that in Upper middle income?
Offer a terse response. 0.91. What is the ratio of the Coal rent(as % of GDP) in 1971 in East Asia (developing only) to that in Upper middle income?
Ensure brevity in your answer.  0.86. What is the ratio of the Coal rent(as % of GDP) in 1972 in East Asia (developing only) to that in Upper middle income?
Your response must be concise. 0.48. What is the ratio of the Coal rent(as % of GDP) of 1973 in East Asia (developing only) to that in Upper middle income?
Make the answer very short. 0.24. What is the ratio of the Coal rent(as % of GDP) of 1970 in Low & middle income to that in Lower middle income?
Provide a short and direct response. 0.35. What is the ratio of the Coal rent(as % of GDP) of 1971 in Low & middle income to that in Lower middle income?
Offer a terse response. 0.33. What is the ratio of the Coal rent(as % of GDP) in 1972 in Low & middle income to that in Lower middle income?
Offer a terse response. 0.31. What is the ratio of the Coal rent(as % of GDP) of 1973 in Low & middle income to that in Lower middle income?
Your answer should be very brief. 0.3. What is the ratio of the Coal rent(as % of GDP) in 1970 in Low & middle income to that in Middle income?
Provide a short and direct response. 0.96. What is the ratio of the Coal rent(as % of GDP) in 1971 in Low & middle income to that in Middle income?
Your response must be concise. 0.96. What is the ratio of the Coal rent(as % of GDP) in 1972 in Low & middle income to that in Middle income?
Ensure brevity in your answer.  0.96. What is the ratio of the Coal rent(as % of GDP) of 1973 in Low & middle income to that in Middle income?
Your answer should be compact. 0.96. What is the ratio of the Coal rent(as % of GDP) of 1970 in Low & middle income to that in South Asia?
Offer a very short reply. 0.21. What is the ratio of the Coal rent(as % of GDP) in 1971 in Low & middle income to that in South Asia?
Your answer should be compact. 0.2. What is the ratio of the Coal rent(as % of GDP) in 1972 in Low & middle income to that in South Asia?
Ensure brevity in your answer.  0.18. What is the ratio of the Coal rent(as % of GDP) of 1973 in Low & middle income to that in South Asia?
Your answer should be compact. 0.17. What is the ratio of the Coal rent(as % of GDP) of 1970 in Low & middle income to that in Upper middle income?
Provide a short and direct response. 38.77. What is the ratio of the Coal rent(as % of GDP) of 1971 in Low & middle income to that in Upper middle income?
Offer a terse response. 55.66. What is the ratio of the Coal rent(as % of GDP) of 1972 in Low & middle income to that in Upper middle income?
Offer a very short reply. 49.28. What is the ratio of the Coal rent(as % of GDP) of 1973 in Low & middle income to that in Upper middle income?
Ensure brevity in your answer.  37.59. What is the ratio of the Coal rent(as % of GDP) in 1970 in Lower middle income to that in Middle income?
Your response must be concise. 2.78. What is the ratio of the Coal rent(as % of GDP) in 1971 in Lower middle income to that in Middle income?
Keep it short and to the point. 2.9. What is the ratio of the Coal rent(as % of GDP) in 1972 in Lower middle income to that in Middle income?
Ensure brevity in your answer.  3.06. What is the ratio of the Coal rent(as % of GDP) in 1973 in Lower middle income to that in Middle income?
Your response must be concise. 3.2. What is the ratio of the Coal rent(as % of GDP) of 1970 in Lower middle income to that in South Asia?
Keep it short and to the point. 0.6. What is the ratio of the Coal rent(as % of GDP) of 1971 in Lower middle income to that in South Asia?
Provide a short and direct response. 0.61. What is the ratio of the Coal rent(as % of GDP) of 1972 in Lower middle income to that in South Asia?
Your answer should be compact. 0.58. What is the ratio of the Coal rent(as % of GDP) of 1973 in Lower middle income to that in South Asia?
Make the answer very short. 0.56. What is the ratio of the Coal rent(as % of GDP) in 1970 in Lower middle income to that in Upper middle income?
Your response must be concise. 112.03. What is the ratio of the Coal rent(as % of GDP) of 1971 in Lower middle income to that in Upper middle income?
Keep it short and to the point. 167.98. What is the ratio of the Coal rent(as % of GDP) in 1972 in Lower middle income to that in Upper middle income?
Your answer should be very brief. 156.82. What is the ratio of the Coal rent(as % of GDP) of 1973 in Lower middle income to that in Upper middle income?
Keep it short and to the point. 124.82. What is the ratio of the Coal rent(as % of GDP) of 1970 in Middle income to that in South Asia?
Give a very brief answer. 0.22. What is the ratio of the Coal rent(as % of GDP) in 1971 in Middle income to that in South Asia?
Offer a terse response. 0.21. What is the ratio of the Coal rent(as % of GDP) of 1972 in Middle income to that in South Asia?
Keep it short and to the point. 0.19. What is the ratio of the Coal rent(as % of GDP) of 1973 in Middle income to that in South Asia?
Ensure brevity in your answer.  0.17. What is the ratio of the Coal rent(as % of GDP) in 1970 in Middle income to that in Upper middle income?
Your response must be concise. 40.36. What is the ratio of the Coal rent(as % of GDP) of 1971 in Middle income to that in Upper middle income?
Offer a very short reply. 58.01. What is the ratio of the Coal rent(as % of GDP) of 1972 in Middle income to that in Upper middle income?
Keep it short and to the point. 51.25. What is the ratio of the Coal rent(as % of GDP) in 1973 in Middle income to that in Upper middle income?
Your response must be concise. 39.04. What is the ratio of the Coal rent(as % of GDP) in 1970 in South Asia to that in Upper middle income?
Ensure brevity in your answer.  187.05. What is the ratio of the Coal rent(as % of GDP) in 1971 in South Asia to that in Upper middle income?
Ensure brevity in your answer.  273.74. What is the ratio of the Coal rent(as % of GDP) of 1972 in South Asia to that in Upper middle income?
Your answer should be compact. 270.32. What is the ratio of the Coal rent(as % of GDP) of 1973 in South Asia to that in Upper middle income?
Your answer should be compact. 224.18. What is the difference between the highest and the second highest Coal rent(as % of GDP) of 1970?
Make the answer very short. 0.01. What is the difference between the highest and the second highest Coal rent(as % of GDP) in 1971?
Provide a succinct answer. 0.02. What is the difference between the highest and the second highest Coal rent(as % of GDP) of 1972?
Provide a short and direct response. 0.03. What is the difference between the highest and the second highest Coal rent(as % of GDP) of 1973?
Give a very brief answer. 0.04. What is the difference between the highest and the lowest Coal rent(as % of GDP) in 1970?
Offer a very short reply. 0.03. What is the difference between the highest and the lowest Coal rent(as % of GDP) in 1971?
Give a very brief answer. 0.06. What is the difference between the highest and the lowest Coal rent(as % of GDP) in 1972?
Keep it short and to the point. 0.08. What is the difference between the highest and the lowest Coal rent(as % of GDP) in 1973?
Ensure brevity in your answer.  0.1. 